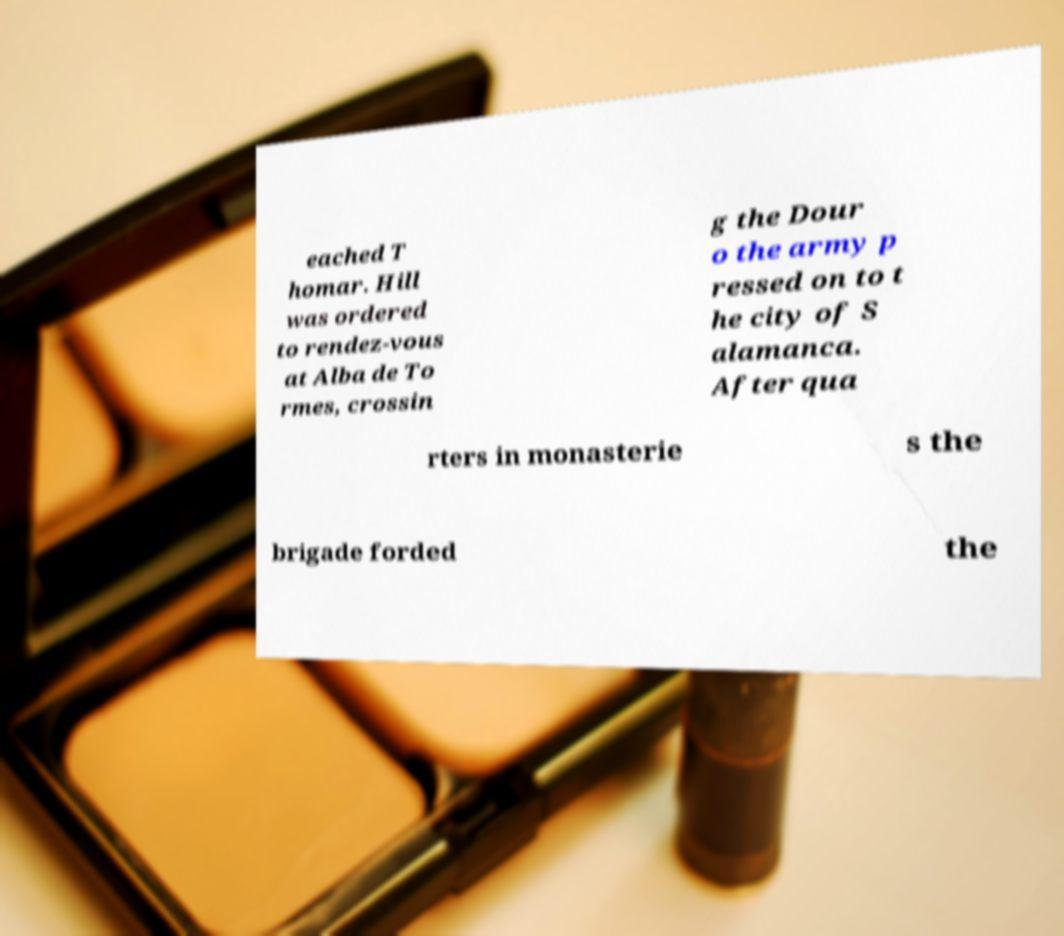Can you read and provide the text displayed in the image?This photo seems to have some interesting text. Can you extract and type it out for me? eached T homar. Hill was ordered to rendez-vous at Alba de To rmes, crossin g the Dour o the army p ressed on to t he city of S alamanca. After qua rters in monasterie s the brigade forded the 